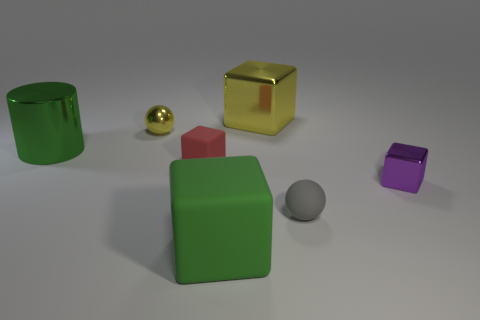Subtract all cyan cubes. Subtract all purple balls. How many cubes are left? 4 Add 3 large yellow shiny balls. How many objects exist? 10 Subtract all blocks. How many objects are left? 3 Add 4 large green matte cubes. How many large green matte cubes are left? 5 Add 5 tiny cyan metallic blocks. How many tiny cyan metallic blocks exist? 5 Subtract 1 yellow spheres. How many objects are left? 6 Subtract all gray metallic things. Subtract all yellow spheres. How many objects are left? 6 